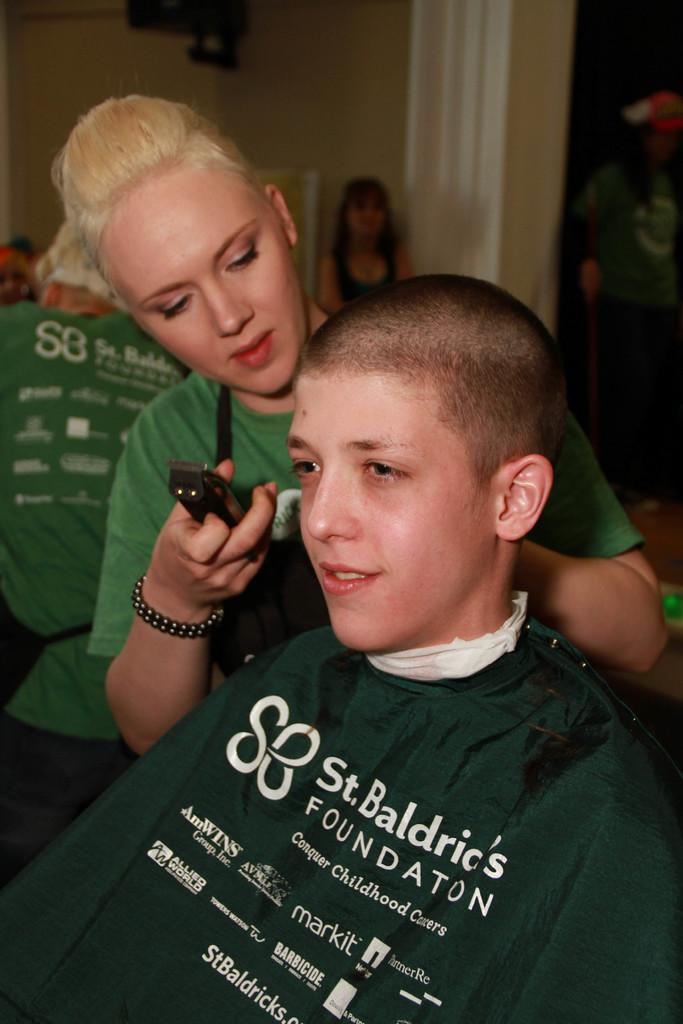Who is the main subject in the image? There is a woman in the image. What is the woman holding in her hand? The woman is holding an object in her hand. What can be seen in the background of the image? There are people and a wall visible in the background of the image. What type of knowledge can be seen on the coast in the image? There is no coast or knowledge present in the image; it features a woman holding an object and a background with people and a wall. 